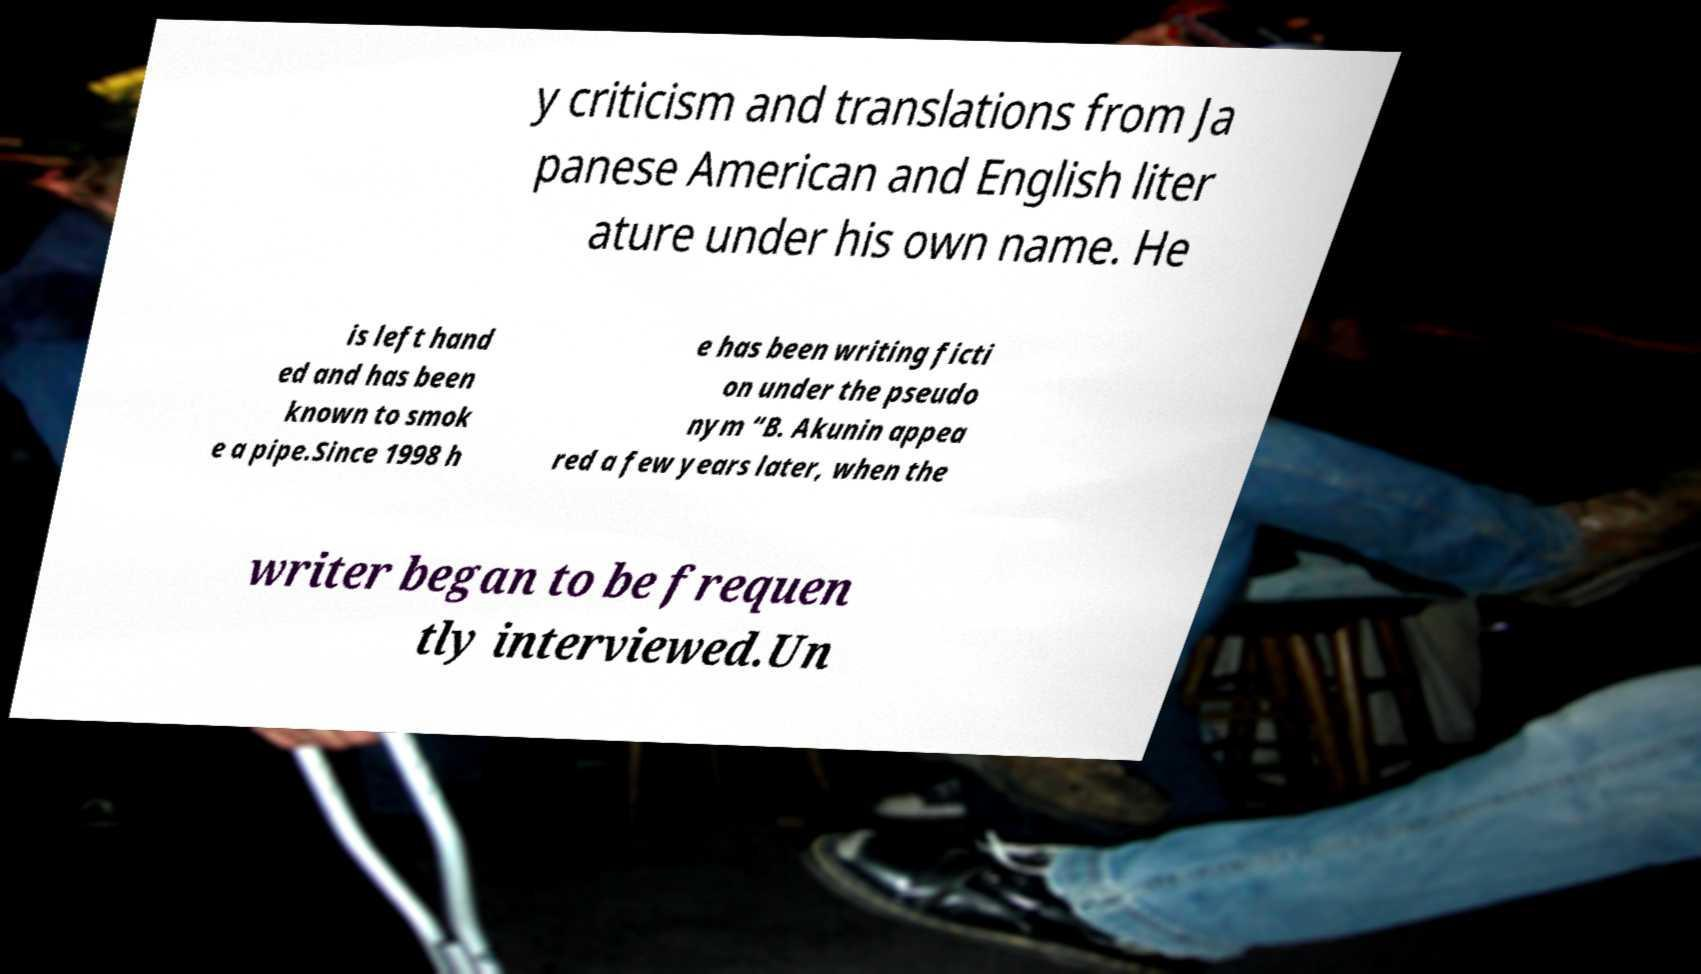Could you extract and type out the text from this image? y criticism and translations from Ja panese American and English liter ature under his own name. He is left hand ed and has been known to smok e a pipe.Since 1998 h e has been writing ficti on under the pseudo nym “B. Akunin appea red a few years later, when the writer began to be frequen tly interviewed.Un 